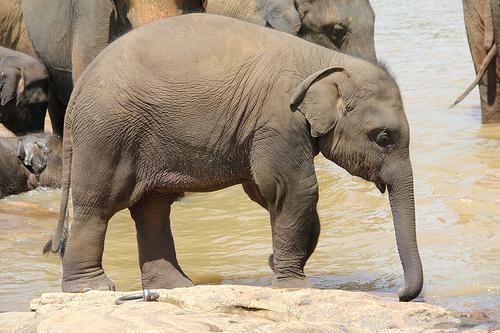How many eyes can be seen on the elephant?
Give a very brief answer. 1. 